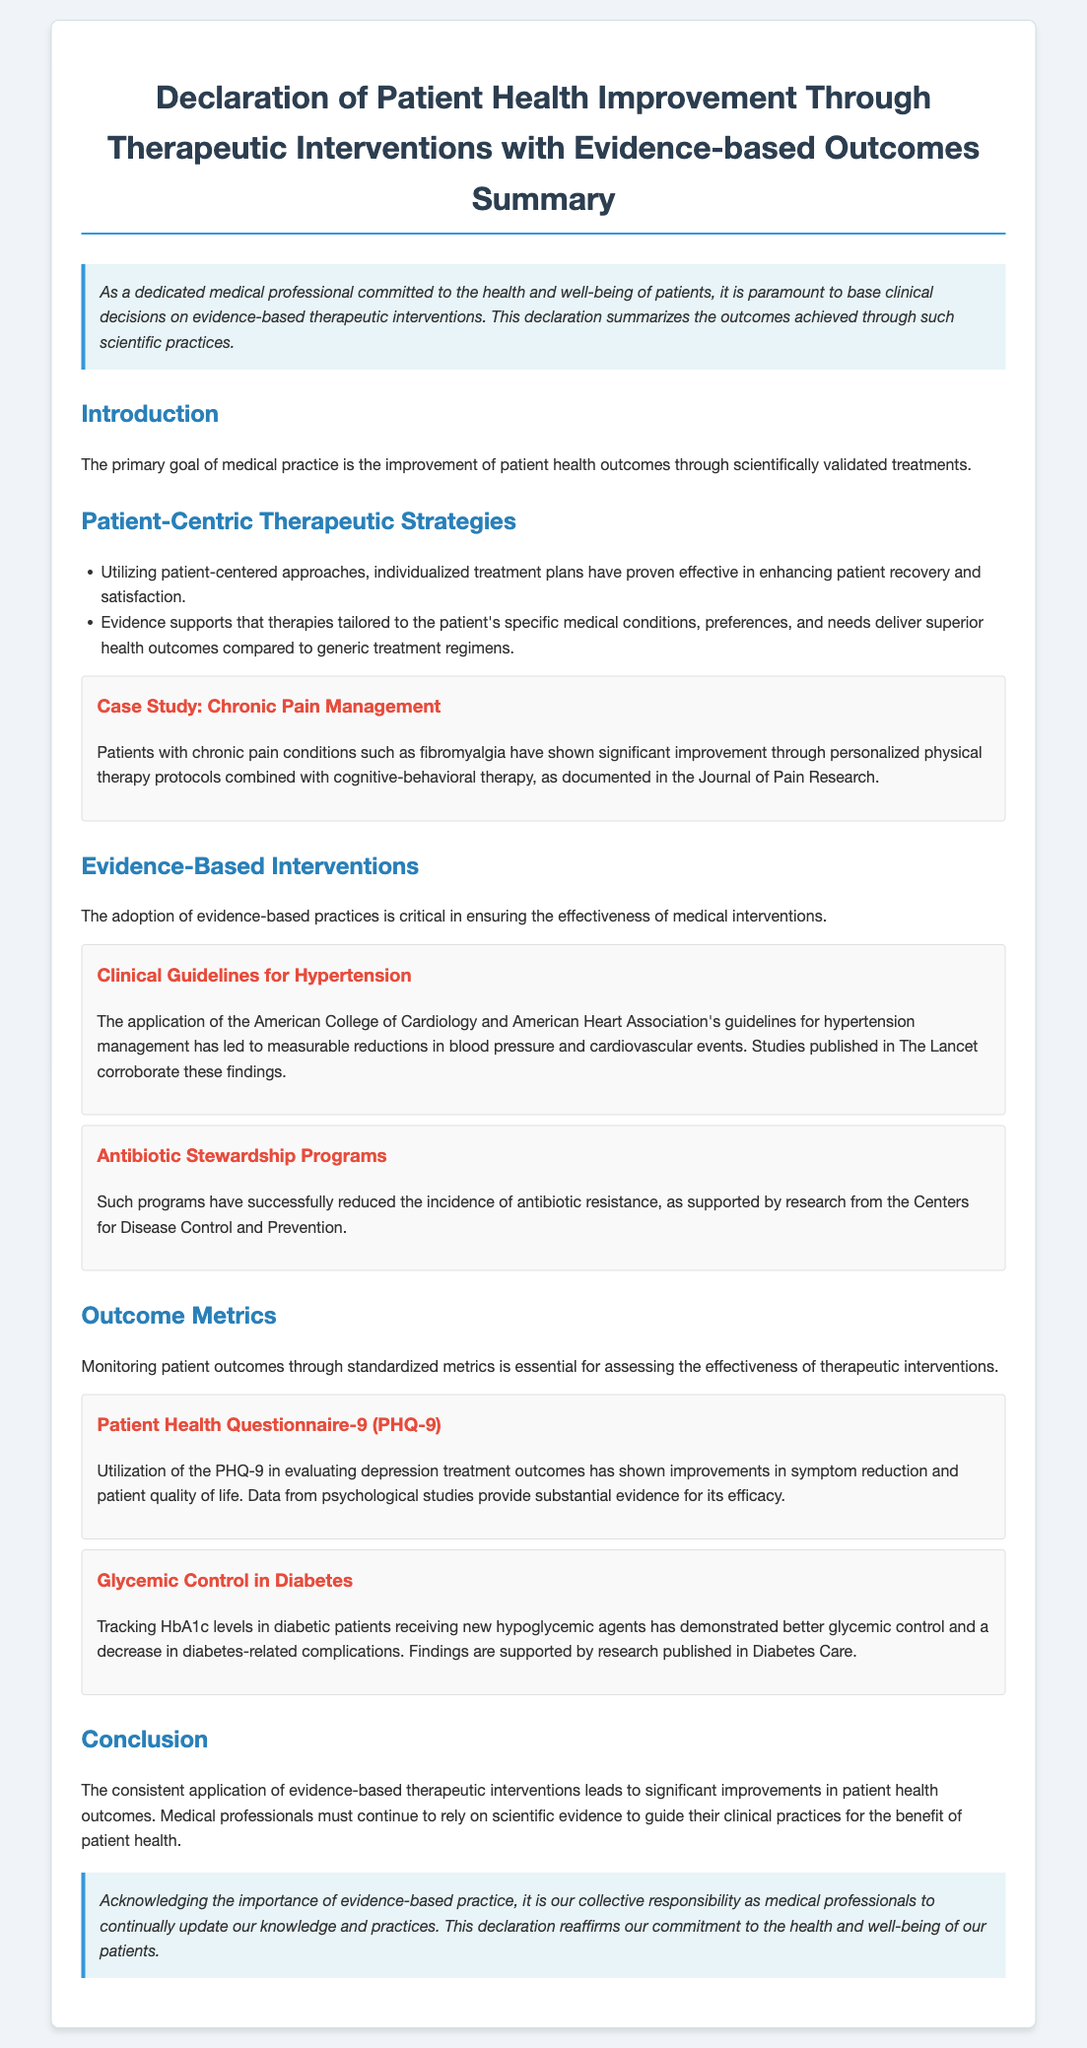What is the title of the document? The title is stated at the top of the document, which summarizes its focus on improving patient health outcomes.
Answer: Declaration of Patient Health Improvement Through Therapeutic Interventions with Evidence-based Outcomes Summary What are two strategies mentioned for patient-centric therapeutic approaches? The bullet points in the document outline specific strategies that enhance patient recovery and satisfaction.
Answer: Individualized treatment plans and tailored therapies Which journal is cited for the chronic pain management case study? The case study reference provides the name of the journal that documented the improvement in chronic pain rehabilitation.
Answer: Journal of Pain Research What is the purpose of monitoring patient outcomes according to the document? The document discusses the significance of standardized metrics in assessing therapeutic intervention effectiveness.
Answer: Assessing effectiveness Which two organizations' guidelines for hypertension management are mentioned? The document references specific organizations that provide guidelines crucial for managing hypertension effectively.
Answer: American College of Cardiology and American Heart Association What effect did antibiotic stewardship programs have? The document details the results of implementing these programs through research findings.
Answer: Reduced incidence of antibiotic resistance What measuring tool is mentioned for evaluating depression treatment outcomes? The document includes a specific measure used for tracking depression-related metrics.
Answer: Patient Health Questionnaire-9 (PHQ-9) What condition is studied in relation to glycemic control? The document mentions specific medical conditions linked to the evaluation and tracking of glycemic levels.
Answer: Diabetes What is the overarching commitment reaffirmed in the conclusion? The conclusion emphasizes a key responsibility of medical professionals as stated within the document.
Answer: Commitment to the health and well-being of patients 